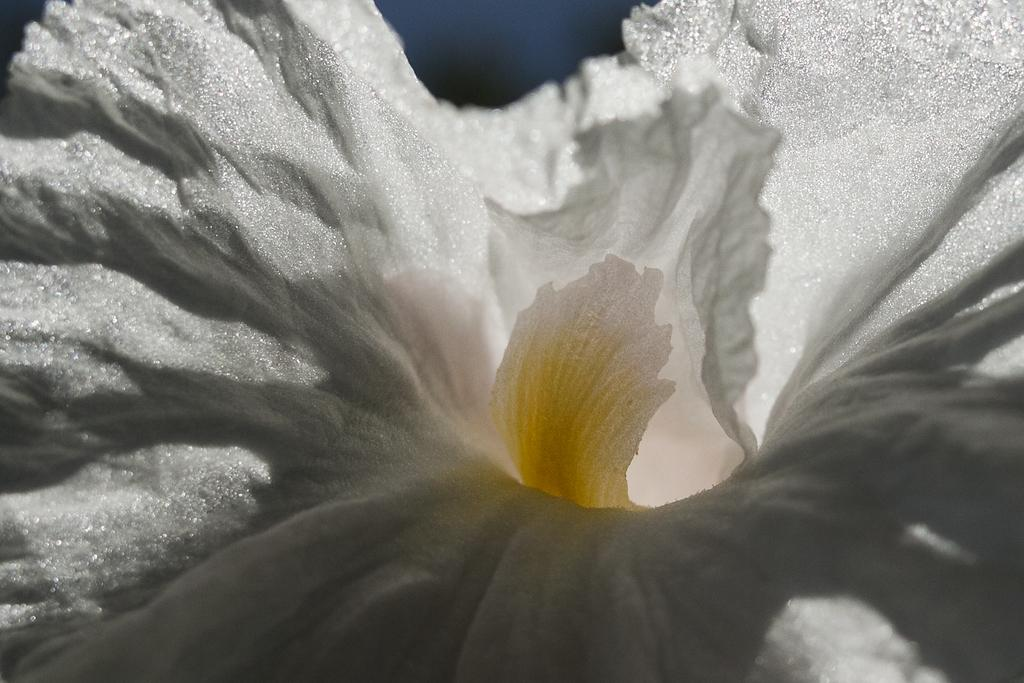What is the main subject of the image? The main subject of the image is a flower. Can you describe the colors of the flower? The flower has white and yellow colors. Does the flower appear to have any special characteristics? Yes, the flower appears to be shining. What can be seen in the background of the image? The background of the image is dark. What type of zephyr is blowing around the flower in the image? There is no zephyr present in the image; it is a still image of a flower. Can you tell me how many achievers are depicted in the image? There are no people or achievers depicted in the image, only a flower. 